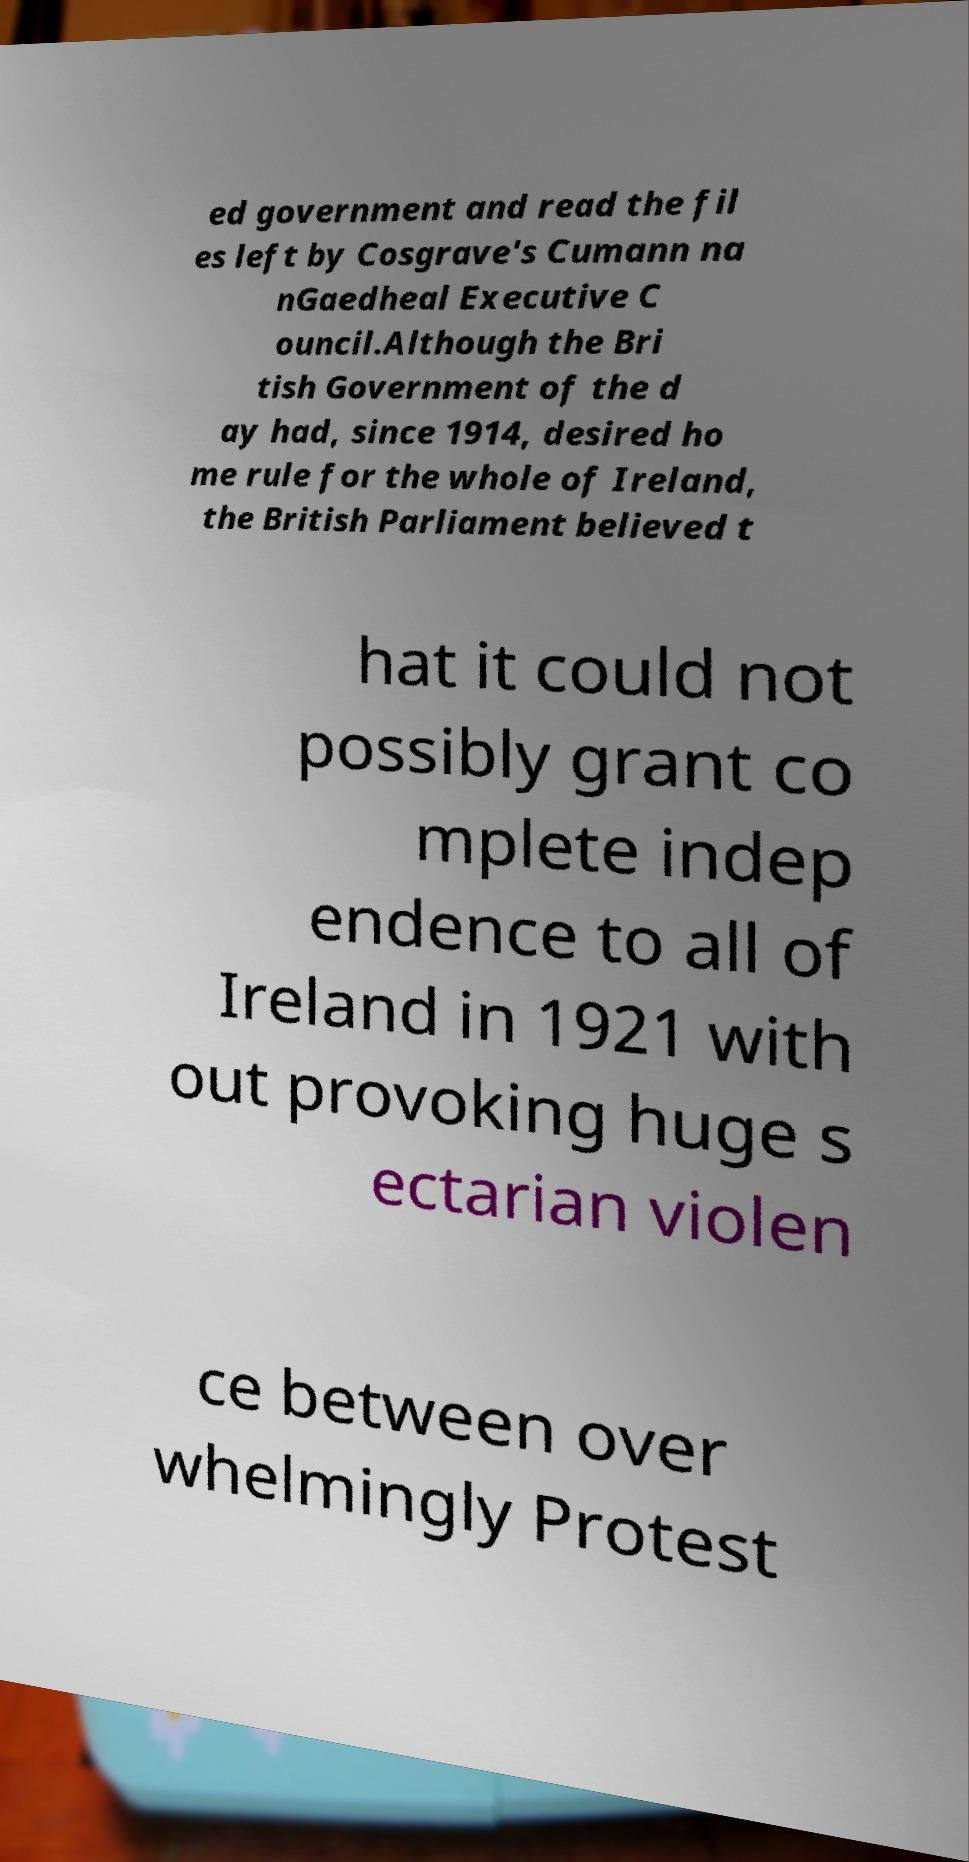There's text embedded in this image that I need extracted. Can you transcribe it verbatim? ed government and read the fil es left by Cosgrave's Cumann na nGaedheal Executive C ouncil.Although the Bri tish Government of the d ay had, since 1914, desired ho me rule for the whole of Ireland, the British Parliament believed t hat it could not possibly grant co mplete indep endence to all of Ireland in 1921 with out provoking huge s ectarian violen ce between over whelmingly Protest 